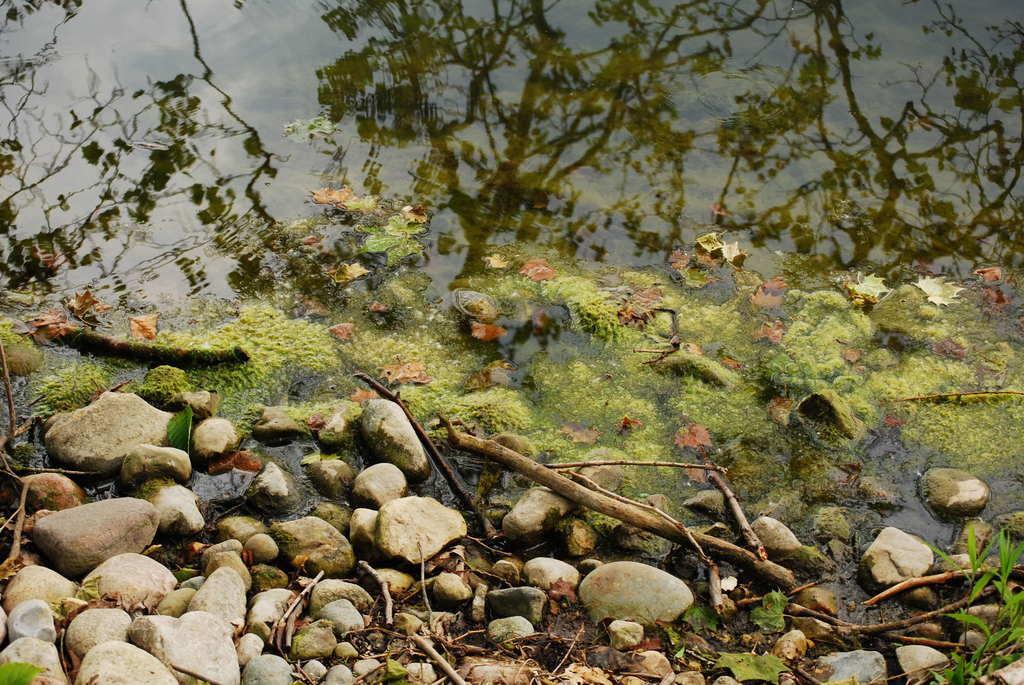Please provide a concise description of this image. In this image we can see there are rocks and wooden sticks at the bottom of the image, in front of them there is a water. On the water we can see there are dry leaves and algae. 